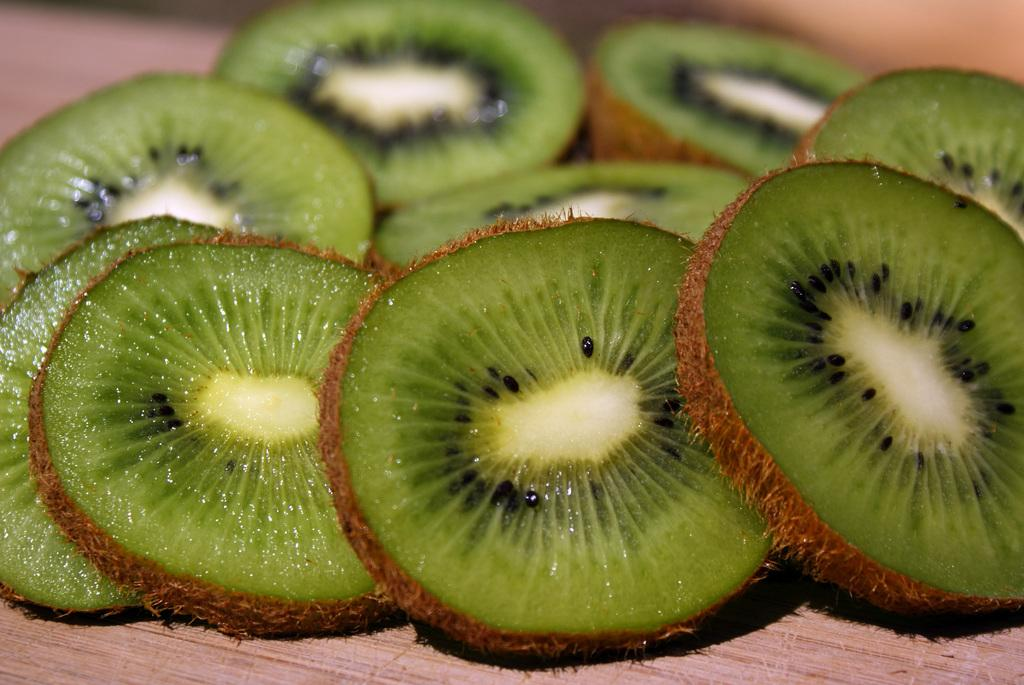What type of food is visible in the image? There are chopped pieces of chico in the image. What type of snow can be seen falling in the image? There is no snow present in the image; it features chopped pieces of chico. How might the chopped chico be used in the image? The image does not show the chopped chico being used for any specific purpose, so it cannot be determined from the image alone. 